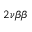<formula> <loc_0><loc_0><loc_500><loc_500>2 { \nu } { \beta } { \beta }</formula> 